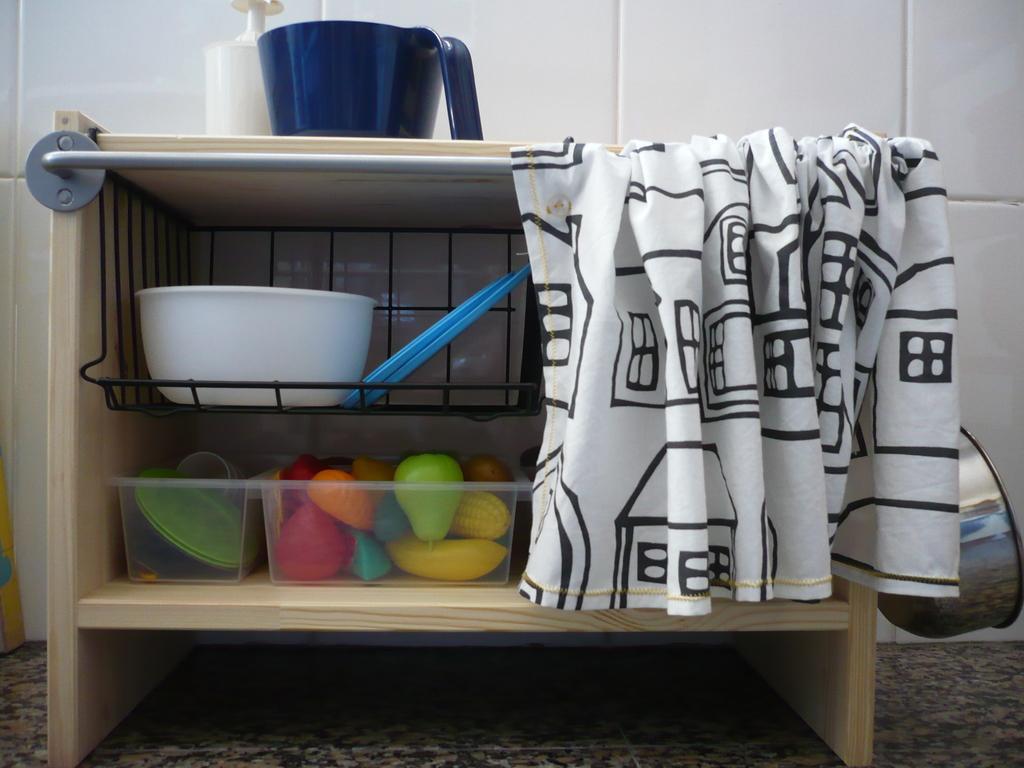Can you describe this image briefly? In the given image i can see the inside view of the wooden object that includes bowl,toys,towel,rod and some other objects. 